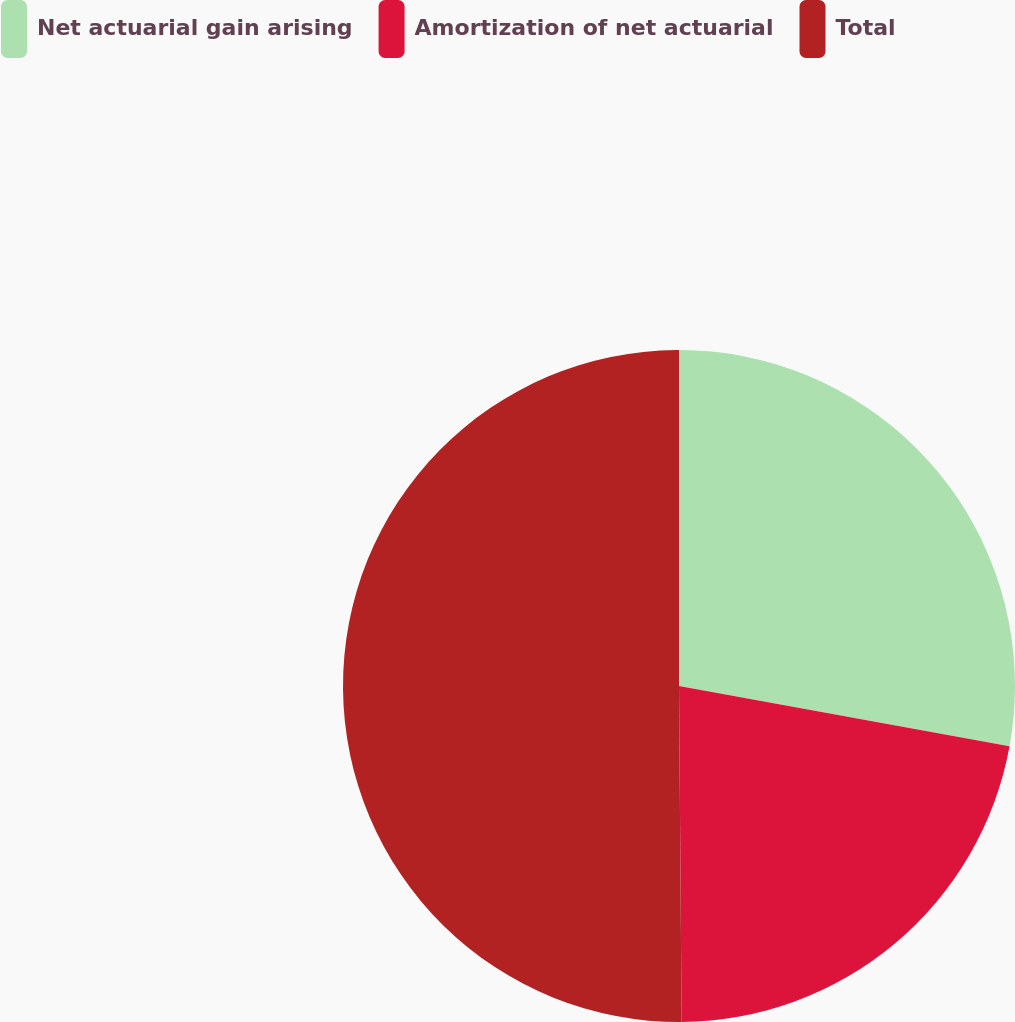Convert chart to OTSL. <chart><loc_0><loc_0><loc_500><loc_500><pie_chart><fcel>Net actuarial gain arising<fcel>Amortization of net actuarial<fcel>Total<nl><fcel>27.87%<fcel>22.0%<fcel>50.12%<nl></chart> 